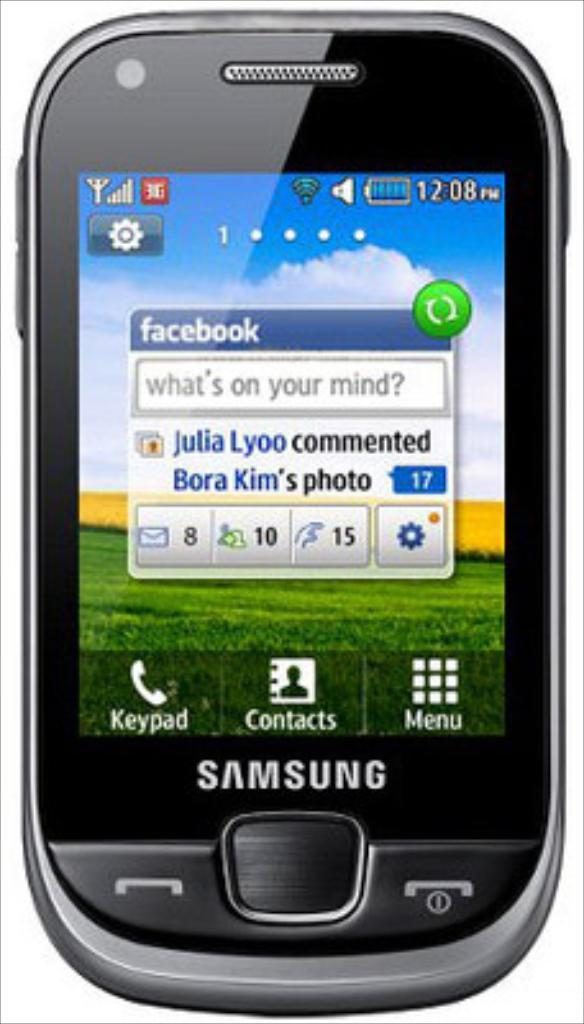<image>
Provide a brief description of the given image. A Samsung phone letting the user know that Julia Lyoo commented on Facebook. 